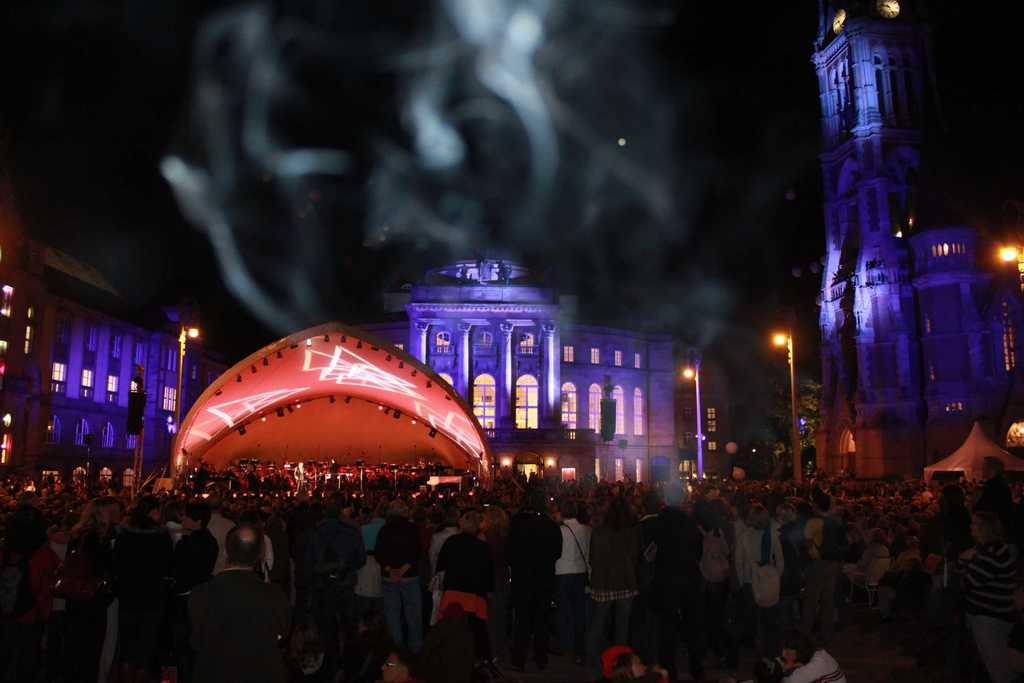How many people are present in the image? There are many people in the image. What type of venue is depicted in the image? There is a function hall in the image. What can be seen attached to the poles in the image? There are lights attached to the poles in the image. What type of structures are visible in the background of the image? There are buildings in the image. What is the condition of the sky in the image? The sky is dark in the image. Can you tell me how many eyes are visible on the cast in the image? There is no cast present in the image, and therefore no eyes can be observed on it. What type of sack is being used to carry the people in the image? There is no sack present in the image, and the people are not being carried by any such object. 